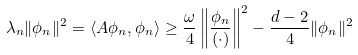Convert formula to latex. <formula><loc_0><loc_0><loc_500><loc_500>\lambda _ { n } \| \phi _ { n } \| ^ { 2 } = \langle A \phi _ { n } , \phi _ { n } \rangle \geq \frac { \omega } { 4 } \left \| \frac { \phi _ { n } } { ( \cdot ) } \right \| ^ { 2 } - \frac { d - 2 } { 4 } \| \phi _ { n } \| ^ { 2 }</formula> 